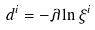Convert formula to latex. <formula><loc_0><loc_0><loc_500><loc_500>d ^ { i } = - \lambda \ln \xi ^ { i }</formula> 